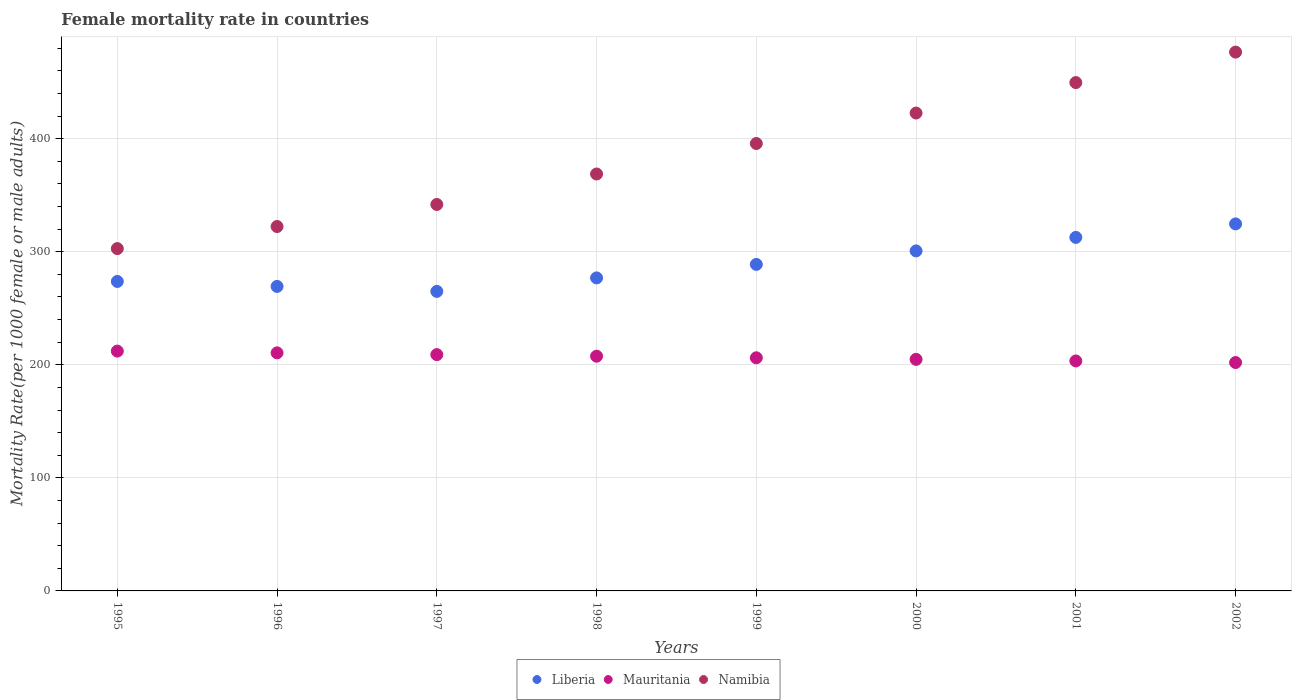How many different coloured dotlines are there?
Keep it short and to the point. 3. What is the female mortality rate in Namibia in 1996?
Your answer should be compact. 322.29. Across all years, what is the maximum female mortality rate in Mauritania?
Your response must be concise. 212.1. Across all years, what is the minimum female mortality rate in Namibia?
Keep it short and to the point. 302.77. What is the total female mortality rate in Namibia in the graph?
Keep it short and to the point. 3080.13. What is the difference between the female mortality rate in Mauritania in 1996 and that in 2001?
Provide a short and direct response. 7.15. What is the difference between the female mortality rate in Liberia in 1998 and the female mortality rate in Mauritania in 1999?
Your answer should be compact. 70.65. What is the average female mortality rate in Liberia per year?
Your response must be concise. 288.94. In the year 1998, what is the difference between the female mortality rate in Namibia and female mortality rate in Liberia?
Ensure brevity in your answer.  91.9. In how many years, is the female mortality rate in Mauritania greater than 180?
Your answer should be very brief. 8. What is the ratio of the female mortality rate in Namibia in 1996 to that in 1997?
Ensure brevity in your answer.  0.94. Is the female mortality rate in Liberia in 1997 less than that in 1999?
Keep it short and to the point. Yes. Is the difference between the female mortality rate in Namibia in 1998 and 2002 greater than the difference between the female mortality rate in Liberia in 1998 and 2002?
Provide a short and direct response. No. What is the difference between the highest and the second highest female mortality rate in Liberia?
Make the answer very short. 11.94. What is the difference between the highest and the lowest female mortality rate in Namibia?
Provide a short and direct response. 173.78. In how many years, is the female mortality rate in Liberia greater than the average female mortality rate in Liberia taken over all years?
Your response must be concise. 3. Is the sum of the female mortality rate in Mauritania in 1995 and 1999 greater than the maximum female mortality rate in Liberia across all years?
Make the answer very short. Yes. Is it the case that in every year, the sum of the female mortality rate in Namibia and female mortality rate in Mauritania  is greater than the female mortality rate in Liberia?
Give a very brief answer. Yes. Does the female mortality rate in Namibia monotonically increase over the years?
Your answer should be very brief. Yes. What is the difference between two consecutive major ticks on the Y-axis?
Provide a succinct answer. 100. Where does the legend appear in the graph?
Give a very brief answer. Bottom center. How many legend labels are there?
Provide a short and direct response. 3. What is the title of the graph?
Provide a succinct answer. Female mortality rate in countries. What is the label or title of the X-axis?
Make the answer very short. Years. What is the label or title of the Y-axis?
Give a very brief answer. Mortality Rate(per 1000 female or male adults). What is the Mortality Rate(per 1000 female or male adults) in Liberia in 1995?
Your response must be concise. 273.69. What is the Mortality Rate(per 1000 female or male adults) of Mauritania in 1995?
Your answer should be compact. 212.1. What is the Mortality Rate(per 1000 female or male adults) in Namibia in 1995?
Offer a terse response. 302.77. What is the Mortality Rate(per 1000 female or male adults) of Liberia in 1996?
Make the answer very short. 269.3. What is the Mortality Rate(per 1000 female or male adults) of Mauritania in 1996?
Your response must be concise. 210.55. What is the Mortality Rate(per 1000 female or male adults) of Namibia in 1996?
Give a very brief answer. 322.29. What is the Mortality Rate(per 1000 female or male adults) of Liberia in 1997?
Give a very brief answer. 264.91. What is the Mortality Rate(per 1000 female or male adults) in Mauritania in 1997?
Make the answer very short. 209. What is the Mortality Rate(per 1000 female or male adults) in Namibia in 1997?
Provide a succinct answer. 341.8. What is the Mortality Rate(per 1000 female or male adults) of Liberia in 1998?
Provide a short and direct response. 276.85. What is the Mortality Rate(per 1000 female or male adults) in Mauritania in 1998?
Keep it short and to the point. 207.6. What is the Mortality Rate(per 1000 female or male adults) of Namibia in 1998?
Your answer should be compact. 368.75. What is the Mortality Rate(per 1000 female or male adults) in Liberia in 1999?
Give a very brief answer. 288.79. What is the Mortality Rate(per 1000 female or male adults) of Mauritania in 1999?
Offer a very short reply. 206.2. What is the Mortality Rate(per 1000 female or male adults) of Namibia in 1999?
Your response must be concise. 395.7. What is the Mortality Rate(per 1000 female or male adults) of Liberia in 2000?
Keep it short and to the point. 300.73. What is the Mortality Rate(per 1000 female or male adults) in Mauritania in 2000?
Your answer should be very brief. 204.8. What is the Mortality Rate(per 1000 female or male adults) in Namibia in 2000?
Ensure brevity in your answer.  422.65. What is the Mortality Rate(per 1000 female or male adults) of Liberia in 2001?
Give a very brief answer. 312.67. What is the Mortality Rate(per 1000 female or male adults) in Mauritania in 2001?
Your answer should be very brief. 203.4. What is the Mortality Rate(per 1000 female or male adults) in Namibia in 2001?
Your answer should be compact. 449.61. What is the Mortality Rate(per 1000 female or male adults) of Liberia in 2002?
Make the answer very short. 324.61. What is the Mortality Rate(per 1000 female or male adults) in Mauritania in 2002?
Your answer should be compact. 202. What is the Mortality Rate(per 1000 female or male adults) in Namibia in 2002?
Your answer should be very brief. 476.56. Across all years, what is the maximum Mortality Rate(per 1000 female or male adults) in Liberia?
Provide a succinct answer. 324.61. Across all years, what is the maximum Mortality Rate(per 1000 female or male adults) of Mauritania?
Your answer should be compact. 212.1. Across all years, what is the maximum Mortality Rate(per 1000 female or male adults) of Namibia?
Provide a short and direct response. 476.56. Across all years, what is the minimum Mortality Rate(per 1000 female or male adults) in Liberia?
Keep it short and to the point. 264.91. Across all years, what is the minimum Mortality Rate(per 1000 female or male adults) in Mauritania?
Your answer should be very brief. 202. Across all years, what is the minimum Mortality Rate(per 1000 female or male adults) of Namibia?
Keep it short and to the point. 302.77. What is the total Mortality Rate(per 1000 female or male adults) of Liberia in the graph?
Provide a short and direct response. 2311.55. What is the total Mortality Rate(per 1000 female or male adults) in Mauritania in the graph?
Provide a short and direct response. 1655.65. What is the total Mortality Rate(per 1000 female or male adults) of Namibia in the graph?
Ensure brevity in your answer.  3080.13. What is the difference between the Mortality Rate(per 1000 female or male adults) in Liberia in 1995 and that in 1996?
Your answer should be very brief. 4.39. What is the difference between the Mortality Rate(per 1000 female or male adults) of Mauritania in 1995 and that in 1996?
Your answer should be compact. 1.55. What is the difference between the Mortality Rate(per 1000 female or male adults) of Namibia in 1995 and that in 1996?
Give a very brief answer. -19.51. What is the difference between the Mortality Rate(per 1000 female or male adults) of Liberia in 1995 and that in 1997?
Your answer should be compact. 8.78. What is the difference between the Mortality Rate(per 1000 female or male adults) in Mauritania in 1995 and that in 1997?
Keep it short and to the point. 3.1. What is the difference between the Mortality Rate(per 1000 female or male adults) of Namibia in 1995 and that in 1997?
Make the answer very short. -39.02. What is the difference between the Mortality Rate(per 1000 female or male adults) of Liberia in 1995 and that in 1998?
Offer a very short reply. -3.16. What is the difference between the Mortality Rate(per 1000 female or male adults) in Mauritania in 1995 and that in 1998?
Your response must be concise. 4.5. What is the difference between the Mortality Rate(per 1000 female or male adults) in Namibia in 1995 and that in 1998?
Your answer should be compact. -65.98. What is the difference between the Mortality Rate(per 1000 female or male adults) in Liberia in 1995 and that in 1999?
Offer a very short reply. -15.1. What is the difference between the Mortality Rate(per 1000 female or male adults) of Mauritania in 1995 and that in 1999?
Your response must be concise. 5.9. What is the difference between the Mortality Rate(per 1000 female or male adults) in Namibia in 1995 and that in 1999?
Your answer should be compact. -92.93. What is the difference between the Mortality Rate(per 1000 female or male adults) in Liberia in 1995 and that in 2000?
Offer a very short reply. -27.03. What is the difference between the Mortality Rate(per 1000 female or male adults) in Mauritania in 1995 and that in 2000?
Offer a terse response. 7.3. What is the difference between the Mortality Rate(per 1000 female or male adults) in Namibia in 1995 and that in 2000?
Your answer should be compact. -119.88. What is the difference between the Mortality Rate(per 1000 female or male adults) in Liberia in 1995 and that in 2001?
Your answer should be very brief. -38.97. What is the difference between the Mortality Rate(per 1000 female or male adults) of Mauritania in 1995 and that in 2001?
Offer a very short reply. 8.7. What is the difference between the Mortality Rate(per 1000 female or male adults) of Namibia in 1995 and that in 2001?
Your answer should be compact. -146.83. What is the difference between the Mortality Rate(per 1000 female or male adults) of Liberia in 1995 and that in 2002?
Make the answer very short. -50.91. What is the difference between the Mortality Rate(per 1000 female or male adults) of Mauritania in 1995 and that in 2002?
Your answer should be compact. 10.1. What is the difference between the Mortality Rate(per 1000 female or male adults) in Namibia in 1995 and that in 2002?
Make the answer very short. -173.78. What is the difference between the Mortality Rate(per 1000 female or male adults) of Liberia in 1996 and that in 1997?
Offer a terse response. 4.39. What is the difference between the Mortality Rate(per 1000 female or male adults) in Mauritania in 1996 and that in 1997?
Provide a succinct answer. 1.55. What is the difference between the Mortality Rate(per 1000 female or male adults) in Namibia in 1996 and that in 1997?
Offer a very short reply. -19.51. What is the difference between the Mortality Rate(per 1000 female or male adults) in Liberia in 1996 and that in 1998?
Give a very brief answer. -7.55. What is the difference between the Mortality Rate(per 1000 female or male adults) in Mauritania in 1996 and that in 1998?
Give a very brief answer. 2.95. What is the difference between the Mortality Rate(per 1000 female or male adults) of Namibia in 1996 and that in 1998?
Your answer should be compact. -46.46. What is the difference between the Mortality Rate(per 1000 female or male adults) of Liberia in 1996 and that in 1999?
Offer a terse response. -19.49. What is the difference between the Mortality Rate(per 1000 female or male adults) of Mauritania in 1996 and that in 1999?
Provide a succinct answer. 4.35. What is the difference between the Mortality Rate(per 1000 female or male adults) in Namibia in 1996 and that in 1999?
Offer a very short reply. -73.42. What is the difference between the Mortality Rate(per 1000 female or male adults) of Liberia in 1996 and that in 2000?
Offer a very short reply. -31.42. What is the difference between the Mortality Rate(per 1000 female or male adults) in Mauritania in 1996 and that in 2000?
Offer a very short reply. 5.75. What is the difference between the Mortality Rate(per 1000 female or male adults) of Namibia in 1996 and that in 2000?
Keep it short and to the point. -100.37. What is the difference between the Mortality Rate(per 1000 female or male adults) of Liberia in 1996 and that in 2001?
Ensure brevity in your answer.  -43.36. What is the difference between the Mortality Rate(per 1000 female or male adults) in Mauritania in 1996 and that in 2001?
Your answer should be very brief. 7.15. What is the difference between the Mortality Rate(per 1000 female or male adults) of Namibia in 1996 and that in 2001?
Your answer should be very brief. -127.32. What is the difference between the Mortality Rate(per 1000 female or male adults) in Liberia in 1996 and that in 2002?
Ensure brevity in your answer.  -55.3. What is the difference between the Mortality Rate(per 1000 female or male adults) of Mauritania in 1996 and that in 2002?
Your response must be concise. 8.55. What is the difference between the Mortality Rate(per 1000 female or male adults) of Namibia in 1996 and that in 2002?
Your answer should be very brief. -154.27. What is the difference between the Mortality Rate(per 1000 female or male adults) of Liberia in 1997 and that in 1998?
Keep it short and to the point. -11.94. What is the difference between the Mortality Rate(per 1000 female or male adults) of Mauritania in 1997 and that in 1998?
Your answer should be compact. 1.4. What is the difference between the Mortality Rate(per 1000 female or male adults) in Namibia in 1997 and that in 1998?
Your response must be concise. -26.95. What is the difference between the Mortality Rate(per 1000 female or male adults) of Liberia in 1997 and that in 1999?
Provide a short and direct response. -23.88. What is the difference between the Mortality Rate(per 1000 female or male adults) in Namibia in 1997 and that in 1999?
Provide a succinct answer. -53.9. What is the difference between the Mortality Rate(per 1000 female or male adults) of Liberia in 1997 and that in 2000?
Your response must be concise. -35.81. What is the difference between the Mortality Rate(per 1000 female or male adults) in Mauritania in 1997 and that in 2000?
Offer a terse response. 4.2. What is the difference between the Mortality Rate(per 1000 female or male adults) in Namibia in 1997 and that in 2000?
Keep it short and to the point. -80.86. What is the difference between the Mortality Rate(per 1000 female or male adults) of Liberia in 1997 and that in 2001?
Ensure brevity in your answer.  -47.75. What is the difference between the Mortality Rate(per 1000 female or male adults) of Namibia in 1997 and that in 2001?
Your response must be concise. -107.81. What is the difference between the Mortality Rate(per 1000 female or male adults) in Liberia in 1997 and that in 2002?
Your answer should be very brief. -59.69. What is the difference between the Mortality Rate(per 1000 female or male adults) of Namibia in 1997 and that in 2002?
Ensure brevity in your answer.  -134.76. What is the difference between the Mortality Rate(per 1000 female or male adults) in Liberia in 1998 and that in 1999?
Provide a succinct answer. -11.94. What is the difference between the Mortality Rate(per 1000 female or male adults) of Namibia in 1998 and that in 1999?
Your response must be concise. -26.95. What is the difference between the Mortality Rate(per 1000 female or male adults) of Liberia in 1998 and that in 2000?
Your response must be concise. -23.88. What is the difference between the Mortality Rate(per 1000 female or male adults) in Mauritania in 1998 and that in 2000?
Offer a very short reply. 2.8. What is the difference between the Mortality Rate(per 1000 female or male adults) of Namibia in 1998 and that in 2000?
Your response must be concise. -53.9. What is the difference between the Mortality Rate(per 1000 female or male adults) of Liberia in 1998 and that in 2001?
Your answer should be compact. -35.81. What is the difference between the Mortality Rate(per 1000 female or male adults) of Namibia in 1998 and that in 2001?
Provide a succinct answer. -80.86. What is the difference between the Mortality Rate(per 1000 female or male adults) in Liberia in 1998 and that in 2002?
Ensure brevity in your answer.  -47.75. What is the difference between the Mortality Rate(per 1000 female or male adults) of Namibia in 1998 and that in 2002?
Provide a short and direct response. -107.81. What is the difference between the Mortality Rate(per 1000 female or male adults) of Liberia in 1999 and that in 2000?
Offer a very short reply. -11.94. What is the difference between the Mortality Rate(per 1000 female or male adults) in Namibia in 1999 and that in 2000?
Ensure brevity in your answer.  -26.95. What is the difference between the Mortality Rate(per 1000 female or male adults) of Liberia in 1999 and that in 2001?
Offer a very short reply. -23.88. What is the difference between the Mortality Rate(per 1000 female or male adults) in Namibia in 1999 and that in 2001?
Make the answer very short. -53.9. What is the difference between the Mortality Rate(per 1000 female or male adults) in Liberia in 1999 and that in 2002?
Provide a succinct answer. -35.81. What is the difference between the Mortality Rate(per 1000 female or male adults) of Namibia in 1999 and that in 2002?
Offer a terse response. -80.86. What is the difference between the Mortality Rate(per 1000 female or male adults) of Liberia in 2000 and that in 2001?
Give a very brief answer. -11.94. What is the difference between the Mortality Rate(per 1000 female or male adults) of Mauritania in 2000 and that in 2001?
Give a very brief answer. 1.4. What is the difference between the Mortality Rate(per 1000 female or male adults) of Namibia in 2000 and that in 2001?
Your answer should be compact. -26.95. What is the difference between the Mortality Rate(per 1000 female or male adults) of Liberia in 2000 and that in 2002?
Your response must be concise. -23.88. What is the difference between the Mortality Rate(per 1000 female or male adults) of Mauritania in 2000 and that in 2002?
Give a very brief answer. 2.8. What is the difference between the Mortality Rate(per 1000 female or male adults) in Namibia in 2000 and that in 2002?
Your answer should be very brief. -53.9. What is the difference between the Mortality Rate(per 1000 female or male adults) of Liberia in 2001 and that in 2002?
Your answer should be very brief. -11.94. What is the difference between the Mortality Rate(per 1000 female or male adults) of Namibia in 2001 and that in 2002?
Keep it short and to the point. -26.95. What is the difference between the Mortality Rate(per 1000 female or male adults) of Liberia in 1995 and the Mortality Rate(per 1000 female or male adults) of Mauritania in 1996?
Keep it short and to the point. 63.14. What is the difference between the Mortality Rate(per 1000 female or male adults) in Liberia in 1995 and the Mortality Rate(per 1000 female or male adults) in Namibia in 1996?
Your answer should be very brief. -48.59. What is the difference between the Mortality Rate(per 1000 female or male adults) of Mauritania in 1995 and the Mortality Rate(per 1000 female or male adults) of Namibia in 1996?
Give a very brief answer. -110.18. What is the difference between the Mortality Rate(per 1000 female or male adults) of Liberia in 1995 and the Mortality Rate(per 1000 female or male adults) of Mauritania in 1997?
Keep it short and to the point. 64.69. What is the difference between the Mortality Rate(per 1000 female or male adults) of Liberia in 1995 and the Mortality Rate(per 1000 female or male adults) of Namibia in 1997?
Provide a succinct answer. -68.1. What is the difference between the Mortality Rate(per 1000 female or male adults) of Mauritania in 1995 and the Mortality Rate(per 1000 female or male adults) of Namibia in 1997?
Your response must be concise. -129.69. What is the difference between the Mortality Rate(per 1000 female or male adults) in Liberia in 1995 and the Mortality Rate(per 1000 female or male adults) in Mauritania in 1998?
Provide a short and direct response. 66.09. What is the difference between the Mortality Rate(per 1000 female or male adults) of Liberia in 1995 and the Mortality Rate(per 1000 female or male adults) of Namibia in 1998?
Provide a succinct answer. -95.06. What is the difference between the Mortality Rate(per 1000 female or male adults) of Mauritania in 1995 and the Mortality Rate(per 1000 female or male adults) of Namibia in 1998?
Make the answer very short. -156.65. What is the difference between the Mortality Rate(per 1000 female or male adults) in Liberia in 1995 and the Mortality Rate(per 1000 female or male adults) in Mauritania in 1999?
Provide a succinct answer. 67.5. What is the difference between the Mortality Rate(per 1000 female or male adults) of Liberia in 1995 and the Mortality Rate(per 1000 female or male adults) of Namibia in 1999?
Your response must be concise. -122.01. What is the difference between the Mortality Rate(per 1000 female or male adults) of Mauritania in 1995 and the Mortality Rate(per 1000 female or male adults) of Namibia in 1999?
Offer a very short reply. -183.6. What is the difference between the Mortality Rate(per 1000 female or male adults) in Liberia in 1995 and the Mortality Rate(per 1000 female or male adults) in Mauritania in 2000?
Offer a very short reply. 68.89. What is the difference between the Mortality Rate(per 1000 female or male adults) of Liberia in 1995 and the Mortality Rate(per 1000 female or male adults) of Namibia in 2000?
Offer a terse response. -148.96. What is the difference between the Mortality Rate(per 1000 female or male adults) of Mauritania in 1995 and the Mortality Rate(per 1000 female or male adults) of Namibia in 2000?
Offer a very short reply. -210.55. What is the difference between the Mortality Rate(per 1000 female or male adults) in Liberia in 1995 and the Mortality Rate(per 1000 female or male adults) in Mauritania in 2001?
Provide a short and direct response. 70.3. What is the difference between the Mortality Rate(per 1000 female or male adults) of Liberia in 1995 and the Mortality Rate(per 1000 female or male adults) of Namibia in 2001?
Provide a succinct answer. -175.91. What is the difference between the Mortality Rate(per 1000 female or male adults) of Mauritania in 1995 and the Mortality Rate(per 1000 female or male adults) of Namibia in 2001?
Offer a very short reply. -237.5. What is the difference between the Mortality Rate(per 1000 female or male adults) of Liberia in 1995 and the Mortality Rate(per 1000 female or male adults) of Mauritania in 2002?
Ensure brevity in your answer.  71.69. What is the difference between the Mortality Rate(per 1000 female or male adults) in Liberia in 1995 and the Mortality Rate(per 1000 female or male adults) in Namibia in 2002?
Your answer should be very brief. -202.86. What is the difference between the Mortality Rate(per 1000 female or male adults) in Mauritania in 1995 and the Mortality Rate(per 1000 female or male adults) in Namibia in 2002?
Ensure brevity in your answer.  -264.45. What is the difference between the Mortality Rate(per 1000 female or male adults) of Liberia in 1996 and the Mortality Rate(per 1000 female or male adults) of Mauritania in 1997?
Keep it short and to the point. 60.3. What is the difference between the Mortality Rate(per 1000 female or male adults) of Liberia in 1996 and the Mortality Rate(per 1000 female or male adults) of Namibia in 1997?
Your answer should be compact. -72.49. What is the difference between the Mortality Rate(per 1000 female or male adults) of Mauritania in 1996 and the Mortality Rate(per 1000 female or male adults) of Namibia in 1997?
Give a very brief answer. -131.25. What is the difference between the Mortality Rate(per 1000 female or male adults) in Liberia in 1996 and the Mortality Rate(per 1000 female or male adults) in Mauritania in 1998?
Offer a terse response. 61.7. What is the difference between the Mortality Rate(per 1000 female or male adults) in Liberia in 1996 and the Mortality Rate(per 1000 female or male adults) in Namibia in 1998?
Offer a very short reply. -99.45. What is the difference between the Mortality Rate(per 1000 female or male adults) in Mauritania in 1996 and the Mortality Rate(per 1000 female or male adults) in Namibia in 1998?
Your answer should be very brief. -158.2. What is the difference between the Mortality Rate(per 1000 female or male adults) of Liberia in 1996 and the Mortality Rate(per 1000 female or male adults) of Mauritania in 1999?
Your answer should be compact. 63.1. What is the difference between the Mortality Rate(per 1000 female or male adults) of Liberia in 1996 and the Mortality Rate(per 1000 female or male adults) of Namibia in 1999?
Your answer should be very brief. -126.4. What is the difference between the Mortality Rate(per 1000 female or male adults) in Mauritania in 1996 and the Mortality Rate(per 1000 female or male adults) in Namibia in 1999?
Your response must be concise. -185.15. What is the difference between the Mortality Rate(per 1000 female or male adults) of Liberia in 1996 and the Mortality Rate(per 1000 female or male adults) of Mauritania in 2000?
Your answer should be compact. 64.5. What is the difference between the Mortality Rate(per 1000 female or male adults) of Liberia in 1996 and the Mortality Rate(per 1000 female or male adults) of Namibia in 2000?
Provide a short and direct response. -153.35. What is the difference between the Mortality Rate(per 1000 female or male adults) of Mauritania in 1996 and the Mortality Rate(per 1000 female or male adults) of Namibia in 2000?
Your answer should be compact. -212.1. What is the difference between the Mortality Rate(per 1000 female or male adults) in Liberia in 1996 and the Mortality Rate(per 1000 female or male adults) in Mauritania in 2001?
Your answer should be compact. 65.9. What is the difference between the Mortality Rate(per 1000 female or male adults) in Liberia in 1996 and the Mortality Rate(per 1000 female or male adults) in Namibia in 2001?
Give a very brief answer. -180.3. What is the difference between the Mortality Rate(per 1000 female or male adults) in Mauritania in 1996 and the Mortality Rate(per 1000 female or male adults) in Namibia in 2001?
Make the answer very short. -239.05. What is the difference between the Mortality Rate(per 1000 female or male adults) in Liberia in 1996 and the Mortality Rate(per 1000 female or male adults) in Mauritania in 2002?
Your answer should be compact. 67.3. What is the difference between the Mortality Rate(per 1000 female or male adults) of Liberia in 1996 and the Mortality Rate(per 1000 female or male adults) of Namibia in 2002?
Your response must be concise. -207.25. What is the difference between the Mortality Rate(per 1000 female or male adults) in Mauritania in 1996 and the Mortality Rate(per 1000 female or male adults) in Namibia in 2002?
Offer a very short reply. -266.01. What is the difference between the Mortality Rate(per 1000 female or male adults) in Liberia in 1997 and the Mortality Rate(per 1000 female or male adults) in Mauritania in 1998?
Ensure brevity in your answer.  57.31. What is the difference between the Mortality Rate(per 1000 female or male adults) of Liberia in 1997 and the Mortality Rate(per 1000 female or male adults) of Namibia in 1998?
Your answer should be very brief. -103.84. What is the difference between the Mortality Rate(per 1000 female or male adults) of Mauritania in 1997 and the Mortality Rate(per 1000 female or male adults) of Namibia in 1998?
Ensure brevity in your answer.  -159.75. What is the difference between the Mortality Rate(per 1000 female or male adults) of Liberia in 1997 and the Mortality Rate(per 1000 female or male adults) of Mauritania in 1999?
Provide a succinct answer. 58.71. What is the difference between the Mortality Rate(per 1000 female or male adults) in Liberia in 1997 and the Mortality Rate(per 1000 female or male adults) in Namibia in 1999?
Your answer should be very brief. -130.79. What is the difference between the Mortality Rate(per 1000 female or male adults) of Mauritania in 1997 and the Mortality Rate(per 1000 female or male adults) of Namibia in 1999?
Provide a succinct answer. -186.7. What is the difference between the Mortality Rate(per 1000 female or male adults) in Liberia in 1997 and the Mortality Rate(per 1000 female or male adults) in Mauritania in 2000?
Provide a short and direct response. 60.11. What is the difference between the Mortality Rate(per 1000 female or male adults) of Liberia in 1997 and the Mortality Rate(per 1000 female or male adults) of Namibia in 2000?
Provide a short and direct response. -157.74. What is the difference between the Mortality Rate(per 1000 female or male adults) in Mauritania in 1997 and the Mortality Rate(per 1000 female or male adults) in Namibia in 2000?
Give a very brief answer. -213.65. What is the difference between the Mortality Rate(per 1000 female or male adults) in Liberia in 1997 and the Mortality Rate(per 1000 female or male adults) in Mauritania in 2001?
Ensure brevity in your answer.  61.51. What is the difference between the Mortality Rate(per 1000 female or male adults) in Liberia in 1997 and the Mortality Rate(per 1000 female or male adults) in Namibia in 2001?
Your answer should be very brief. -184.69. What is the difference between the Mortality Rate(per 1000 female or male adults) of Mauritania in 1997 and the Mortality Rate(per 1000 female or male adults) of Namibia in 2001?
Provide a succinct answer. -240.61. What is the difference between the Mortality Rate(per 1000 female or male adults) in Liberia in 1997 and the Mortality Rate(per 1000 female or male adults) in Mauritania in 2002?
Your answer should be very brief. 62.91. What is the difference between the Mortality Rate(per 1000 female or male adults) of Liberia in 1997 and the Mortality Rate(per 1000 female or male adults) of Namibia in 2002?
Provide a short and direct response. -211.64. What is the difference between the Mortality Rate(per 1000 female or male adults) of Mauritania in 1997 and the Mortality Rate(per 1000 female or male adults) of Namibia in 2002?
Provide a succinct answer. -267.56. What is the difference between the Mortality Rate(per 1000 female or male adults) of Liberia in 1998 and the Mortality Rate(per 1000 female or male adults) of Mauritania in 1999?
Ensure brevity in your answer.  70.65. What is the difference between the Mortality Rate(per 1000 female or male adults) in Liberia in 1998 and the Mortality Rate(per 1000 female or male adults) in Namibia in 1999?
Your answer should be very brief. -118.85. What is the difference between the Mortality Rate(per 1000 female or male adults) in Mauritania in 1998 and the Mortality Rate(per 1000 female or male adults) in Namibia in 1999?
Provide a short and direct response. -188.1. What is the difference between the Mortality Rate(per 1000 female or male adults) in Liberia in 1998 and the Mortality Rate(per 1000 female or male adults) in Mauritania in 2000?
Make the answer very short. 72.05. What is the difference between the Mortality Rate(per 1000 female or male adults) of Liberia in 1998 and the Mortality Rate(per 1000 female or male adults) of Namibia in 2000?
Give a very brief answer. -145.8. What is the difference between the Mortality Rate(per 1000 female or male adults) in Mauritania in 1998 and the Mortality Rate(per 1000 female or male adults) in Namibia in 2000?
Make the answer very short. -215.05. What is the difference between the Mortality Rate(per 1000 female or male adults) of Liberia in 1998 and the Mortality Rate(per 1000 female or male adults) of Mauritania in 2001?
Give a very brief answer. 73.45. What is the difference between the Mortality Rate(per 1000 female or male adults) of Liberia in 1998 and the Mortality Rate(per 1000 female or male adults) of Namibia in 2001?
Offer a terse response. -172.75. What is the difference between the Mortality Rate(per 1000 female or male adults) of Mauritania in 1998 and the Mortality Rate(per 1000 female or male adults) of Namibia in 2001?
Offer a very short reply. -242.01. What is the difference between the Mortality Rate(per 1000 female or male adults) of Liberia in 1998 and the Mortality Rate(per 1000 female or male adults) of Mauritania in 2002?
Your answer should be compact. 74.85. What is the difference between the Mortality Rate(per 1000 female or male adults) of Liberia in 1998 and the Mortality Rate(per 1000 female or male adults) of Namibia in 2002?
Keep it short and to the point. -199.71. What is the difference between the Mortality Rate(per 1000 female or male adults) of Mauritania in 1998 and the Mortality Rate(per 1000 female or male adults) of Namibia in 2002?
Offer a very short reply. -268.96. What is the difference between the Mortality Rate(per 1000 female or male adults) of Liberia in 1999 and the Mortality Rate(per 1000 female or male adults) of Mauritania in 2000?
Offer a terse response. 83.99. What is the difference between the Mortality Rate(per 1000 female or male adults) in Liberia in 1999 and the Mortality Rate(per 1000 female or male adults) in Namibia in 2000?
Provide a succinct answer. -133.86. What is the difference between the Mortality Rate(per 1000 female or male adults) in Mauritania in 1999 and the Mortality Rate(per 1000 female or male adults) in Namibia in 2000?
Offer a very short reply. -216.45. What is the difference between the Mortality Rate(per 1000 female or male adults) in Liberia in 1999 and the Mortality Rate(per 1000 female or male adults) in Mauritania in 2001?
Provide a short and direct response. 85.39. What is the difference between the Mortality Rate(per 1000 female or male adults) in Liberia in 1999 and the Mortality Rate(per 1000 female or male adults) in Namibia in 2001?
Ensure brevity in your answer.  -160.82. What is the difference between the Mortality Rate(per 1000 female or male adults) of Mauritania in 1999 and the Mortality Rate(per 1000 female or male adults) of Namibia in 2001?
Provide a short and direct response. -243.41. What is the difference between the Mortality Rate(per 1000 female or male adults) in Liberia in 1999 and the Mortality Rate(per 1000 female or male adults) in Mauritania in 2002?
Your answer should be very brief. 86.79. What is the difference between the Mortality Rate(per 1000 female or male adults) of Liberia in 1999 and the Mortality Rate(per 1000 female or male adults) of Namibia in 2002?
Make the answer very short. -187.77. What is the difference between the Mortality Rate(per 1000 female or male adults) in Mauritania in 1999 and the Mortality Rate(per 1000 female or male adults) in Namibia in 2002?
Your answer should be very brief. -270.36. What is the difference between the Mortality Rate(per 1000 female or male adults) in Liberia in 2000 and the Mortality Rate(per 1000 female or male adults) in Mauritania in 2001?
Make the answer very short. 97.33. What is the difference between the Mortality Rate(per 1000 female or male adults) in Liberia in 2000 and the Mortality Rate(per 1000 female or male adults) in Namibia in 2001?
Your answer should be compact. -148.88. What is the difference between the Mortality Rate(per 1000 female or male adults) in Mauritania in 2000 and the Mortality Rate(per 1000 female or male adults) in Namibia in 2001?
Keep it short and to the point. -244.81. What is the difference between the Mortality Rate(per 1000 female or male adults) in Liberia in 2000 and the Mortality Rate(per 1000 female or male adults) in Mauritania in 2002?
Your answer should be compact. 98.73. What is the difference between the Mortality Rate(per 1000 female or male adults) of Liberia in 2000 and the Mortality Rate(per 1000 female or male adults) of Namibia in 2002?
Make the answer very short. -175.83. What is the difference between the Mortality Rate(per 1000 female or male adults) in Mauritania in 2000 and the Mortality Rate(per 1000 female or male adults) in Namibia in 2002?
Make the answer very short. -271.76. What is the difference between the Mortality Rate(per 1000 female or male adults) in Liberia in 2001 and the Mortality Rate(per 1000 female or male adults) in Mauritania in 2002?
Your response must be concise. 110.67. What is the difference between the Mortality Rate(per 1000 female or male adults) in Liberia in 2001 and the Mortality Rate(per 1000 female or male adults) in Namibia in 2002?
Give a very brief answer. -163.89. What is the difference between the Mortality Rate(per 1000 female or male adults) of Mauritania in 2001 and the Mortality Rate(per 1000 female or male adults) of Namibia in 2002?
Ensure brevity in your answer.  -273.16. What is the average Mortality Rate(per 1000 female or male adults) of Liberia per year?
Offer a very short reply. 288.94. What is the average Mortality Rate(per 1000 female or male adults) in Mauritania per year?
Your answer should be compact. 206.96. What is the average Mortality Rate(per 1000 female or male adults) in Namibia per year?
Give a very brief answer. 385.02. In the year 1995, what is the difference between the Mortality Rate(per 1000 female or male adults) in Liberia and Mortality Rate(per 1000 female or male adults) in Mauritania?
Ensure brevity in your answer.  61.59. In the year 1995, what is the difference between the Mortality Rate(per 1000 female or male adults) in Liberia and Mortality Rate(per 1000 female or male adults) in Namibia?
Give a very brief answer. -29.08. In the year 1995, what is the difference between the Mortality Rate(per 1000 female or male adults) in Mauritania and Mortality Rate(per 1000 female or male adults) in Namibia?
Provide a short and direct response. -90.67. In the year 1996, what is the difference between the Mortality Rate(per 1000 female or male adults) in Liberia and Mortality Rate(per 1000 female or male adults) in Mauritania?
Provide a succinct answer. 58.75. In the year 1996, what is the difference between the Mortality Rate(per 1000 female or male adults) of Liberia and Mortality Rate(per 1000 female or male adults) of Namibia?
Keep it short and to the point. -52.98. In the year 1996, what is the difference between the Mortality Rate(per 1000 female or male adults) in Mauritania and Mortality Rate(per 1000 female or male adults) in Namibia?
Provide a short and direct response. -111.73. In the year 1997, what is the difference between the Mortality Rate(per 1000 female or male adults) in Liberia and Mortality Rate(per 1000 female or male adults) in Mauritania?
Make the answer very short. 55.91. In the year 1997, what is the difference between the Mortality Rate(per 1000 female or male adults) in Liberia and Mortality Rate(per 1000 female or male adults) in Namibia?
Give a very brief answer. -76.88. In the year 1997, what is the difference between the Mortality Rate(per 1000 female or male adults) in Mauritania and Mortality Rate(per 1000 female or male adults) in Namibia?
Keep it short and to the point. -132.8. In the year 1998, what is the difference between the Mortality Rate(per 1000 female or male adults) of Liberia and Mortality Rate(per 1000 female or male adults) of Mauritania?
Provide a succinct answer. 69.25. In the year 1998, what is the difference between the Mortality Rate(per 1000 female or male adults) of Liberia and Mortality Rate(per 1000 female or male adults) of Namibia?
Your answer should be very brief. -91.9. In the year 1998, what is the difference between the Mortality Rate(per 1000 female or male adults) of Mauritania and Mortality Rate(per 1000 female or male adults) of Namibia?
Ensure brevity in your answer.  -161.15. In the year 1999, what is the difference between the Mortality Rate(per 1000 female or male adults) in Liberia and Mortality Rate(per 1000 female or male adults) in Mauritania?
Ensure brevity in your answer.  82.59. In the year 1999, what is the difference between the Mortality Rate(per 1000 female or male adults) in Liberia and Mortality Rate(per 1000 female or male adults) in Namibia?
Keep it short and to the point. -106.91. In the year 1999, what is the difference between the Mortality Rate(per 1000 female or male adults) of Mauritania and Mortality Rate(per 1000 female or male adults) of Namibia?
Keep it short and to the point. -189.5. In the year 2000, what is the difference between the Mortality Rate(per 1000 female or male adults) of Liberia and Mortality Rate(per 1000 female or male adults) of Mauritania?
Make the answer very short. 95.93. In the year 2000, what is the difference between the Mortality Rate(per 1000 female or male adults) in Liberia and Mortality Rate(per 1000 female or male adults) in Namibia?
Offer a very short reply. -121.93. In the year 2000, what is the difference between the Mortality Rate(per 1000 female or male adults) of Mauritania and Mortality Rate(per 1000 female or male adults) of Namibia?
Offer a terse response. -217.85. In the year 2001, what is the difference between the Mortality Rate(per 1000 female or male adults) of Liberia and Mortality Rate(per 1000 female or male adults) of Mauritania?
Offer a terse response. 109.27. In the year 2001, what is the difference between the Mortality Rate(per 1000 female or male adults) of Liberia and Mortality Rate(per 1000 female or male adults) of Namibia?
Your answer should be very brief. -136.94. In the year 2001, what is the difference between the Mortality Rate(per 1000 female or male adults) in Mauritania and Mortality Rate(per 1000 female or male adults) in Namibia?
Your answer should be very brief. -246.21. In the year 2002, what is the difference between the Mortality Rate(per 1000 female or male adults) of Liberia and Mortality Rate(per 1000 female or male adults) of Mauritania?
Your answer should be compact. 122.61. In the year 2002, what is the difference between the Mortality Rate(per 1000 female or male adults) in Liberia and Mortality Rate(per 1000 female or male adults) in Namibia?
Offer a very short reply. -151.95. In the year 2002, what is the difference between the Mortality Rate(per 1000 female or male adults) in Mauritania and Mortality Rate(per 1000 female or male adults) in Namibia?
Provide a succinct answer. -274.56. What is the ratio of the Mortality Rate(per 1000 female or male adults) of Liberia in 1995 to that in 1996?
Keep it short and to the point. 1.02. What is the ratio of the Mortality Rate(per 1000 female or male adults) of Mauritania in 1995 to that in 1996?
Offer a terse response. 1.01. What is the ratio of the Mortality Rate(per 1000 female or male adults) in Namibia in 1995 to that in 1996?
Offer a very short reply. 0.94. What is the ratio of the Mortality Rate(per 1000 female or male adults) in Liberia in 1995 to that in 1997?
Offer a terse response. 1.03. What is the ratio of the Mortality Rate(per 1000 female or male adults) of Mauritania in 1995 to that in 1997?
Your answer should be very brief. 1.01. What is the ratio of the Mortality Rate(per 1000 female or male adults) of Namibia in 1995 to that in 1997?
Offer a terse response. 0.89. What is the ratio of the Mortality Rate(per 1000 female or male adults) of Liberia in 1995 to that in 1998?
Keep it short and to the point. 0.99. What is the ratio of the Mortality Rate(per 1000 female or male adults) of Mauritania in 1995 to that in 1998?
Your answer should be compact. 1.02. What is the ratio of the Mortality Rate(per 1000 female or male adults) of Namibia in 1995 to that in 1998?
Make the answer very short. 0.82. What is the ratio of the Mortality Rate(per 1000 female or male adults) of Liberia in 1995 to that in 1999?
Make the answer very short. 0.95. What is the ratio of the Mortality Rate(per 1000 female or male adults) in Mauritania in 1995 to that in 1999?
Keep it short and to the point. 1.03. What is the ratio of the Mortality Rate(per 1000 female or male adults) of Namibia in 1995 to that in 1999?
Give a very brief answer. 0.77. What is the ratio of the Mortality Rate(per 1000 female or male adults) of Liberia in 1995 to that in 2000?
Make the answer very short. 0.91. What is the ratio of the Mortality Rate(per 1000 female or male adults) in Mauritania in 1995 to that in 2000?
Make the answer very short. 1.04. What is the ratio of the Mortality Rate(per 1000 female or male adults) of Namibia in 1995 to that in 2000?
Give a very brief answer. 0.72. What is the ratio of the Mortality Rate(per 1000 female or male adults) of Liberia in 1995 to that in 2001?
Provide a short and direct response. 0.88. What is the ratio of the Mortality Rate(per 1000 female or male adults) of Mauritania in 1995 to that in 2001?
Provide a succinct answer. 1.04. What is the ratio of the Mortality Rate(per 1000 female or male adults) of Namibia in 1995 to that in 2001?
Your answer should be very brief. 0.67. What is the ratio of the Mortality Rate(per 1000 female or male adults) of Liberia in 1995 to that in 2002?
Keep it short and to the point. 0.84. What is the ratio of the Mortality Rate(per 1000 female or male adults) in Namibia in 1995 to that in 2002?
Offer a very short reply. 0.64. What is the ratio of the Mortality Rate(per 1000 female or male adults) in Liberia in 1996 to that in 1997?
Your response must be concise. 1.02. What is the ratio of the Mortality Rate(per 1000 female or male adults) in Mauritania in 1996 to that in 1997?
Offer a terse response. 1.01. What is the ratio of the Mortality Rate(per 1000 female or male adults) in Namibia in 1996 to that in 1997?
Your response must be concise. 0.94. What is the ratio of the Mortality Rate(per 1000 female or male adults) in Liberia in 1996 to that in 1998?
Provide a short and direct response. 0.97. What is the ratio of the Mortality Rate(per 1000 female or male adults) in Mauritania in 1996 to that in 1998?
Make the answer very short. 1.01. What is the ratio of the Mortality Rate(per 1000 female or male adults) in Namibia in 1996 to that in 1998?
Give a very brief answer. 0.87. What is the ratio of the Mortality Rate(per 1000 female or male adults) of Liberia in 1996 to that in 1999?
Make the answer very short. 0.93. What is the ratio of the Mortality Rate(per 1000 female or male adults) of Mauritania in 1996 to that in 1999?
Provide a short and direct response. 1.02. What is the ratio of the Mortality Rate(per 1000 female or male adults) in Namibia in 1996 to that in 1999?
Keep it short and to the point. 0.81. What is the ratio of the Mortality Rate(per 1000 female or male adults) in Liberia in 1996 to that in 2000?
Give a very brief answer. 0.9. What is the ratio of the Mortality Rate(per 1000 female or male adults) in Mauritania in 1996 to that in 2000?
Your response must be concise. 1.03. What is the ratio of the Mortality Rate(per 1000 female or male adults) in Namibia in 1996 to that in 2000?
Your answer should be compact. 0.76. What is the ratio of the Mortality Rate(per 1000 female or male adults) in Liberia in 1996 to that in 2001?
Make the answer very short. 0.86. What is the ratio of the Mortality Rate(per 1000 female or male adults) of Mauritania in 1996 to that in 2001?
Ensure brevity in your answer.  1.04. What is the ratio of the Mortality Rate(per 1000 female or male adults) of Namibia in 1996 to that in 2001?
Make the answer very short. 0.72. What is the ratio of the Mortality Rate(per 1000 female or male adults) in Liberia in 1996 to that in 2002?
Your answer should be compact. 0.83. What is the ratio of the Mortality Rate(per 1000 female or male adults) in Mauritania in 1996 to that in 2002?
Offer a terse response. 1.04. What is the ratio of the Mortality Rate(per 1000 female or male adults) in Namibia in 1996 to that in 2002?
Offer a terse response. 0.68. What is the ratio of the Mortality Rate(per 1000 female or male adults) of Liberia in 1997 to that in 1998?
Offer a terse response. 0.96. What is the ratio of the Mortality Rate(per 1000 female or male adults) of Namibia in 1997 to that in 1998?
Ensure brevity in your answer.  0.93. What is the ratio of the Mortality Rate(per 1000 female or male adults) in Liberia in 1997 to that in 1999?
Give a very brief answer. 0.92. What is the ratio of the Mortality Rate(per 1000 female or male adults) in Mauritania in 1997 to that in 1999?
Keep it short and to the point. 1.01. What is the ratio of the Mortality Rate(per 1000 female or male adults) in Namibia in 1997 to that in 1999?
Offer a terse response. 0.86. What is the ratio of the Mortality Rate(per 1000 female or male adults) in Liberia in 1997 to that in 2000?
Offer a terse response. 0.88. What is the ratio of the Mortality Rate(per 1000 female or male adults) in Mauritania in 1997 to that in 2000?
Ensure brevity in your answer.  1.02. What is the ratio of the Mortality Rate(per 1000 female or male adults) in Namibia in 1997 to that in 2000?
Give a very brief answer. 0.81. What is the ratio of the Mortality Rate(per 1000 female or male adults) in Liberia in 1997 to that in 2001?
Offer a very short reply. 0.85. What is the ratio of the Mortality Rate(per 1000 female or male adults) in Mauritania in 1997 to that in 2001?
Your response must be concise. 1.03. What is the ratio of the Mortality Rate(per 1000 female or male adults) in Namibia in 1997 to that in 2001?
Keep it short and to the point. 0.76. What is the ratio of the Mortality Rate(per 1000 female or male adults) in Liberia in 1997 to that in 2002?
Your answer should be compact. 0.82. What is the ratio of the Mortality Rate(per 1000 female or male adults) of Mauritania in 1997 to that in 2002?
Provide a succinct answer. 1.03. What is the ratio of the Mortality Rate(per 1000 female or male adults) of Namibia in 1997 to that in 2002?
Your answer should be very brief. 0.72. What is the ratio of the Mortality Rate(per 1000 female or male adults) of Liberia in 1998 to that in 1999?
Make the answer very short. 0.96. What is the ratio of the Mortality Rate(per 1000 female or male adults) of Mauritania in 1998 to that in 1999?
Offer a terse response. 1.01. What is the ratio of the Mortality Rate(per 1000 female or male adults) of Namibia in 1998 to that in 1999?
Provide a succinct answer. 0.93. What is the ratio of the Mortality Rate(per 1000 female or male adults) in Liberia in 1998 to that in 2000?
Offer a very short reply. 0.92. What is the ratio of the Mortality Rate(per 1000 female or male adults) in Mauritania in 1998 to that in 2000?
Your answer should be very brief. 1.01. What is the ratio of the Mortality Rate(per 1000 female or male adults) in Namibia in 1998 to that in 2000?
Give a very brief answer. 0.87. What is the ratio of the Mortality Rate(per 1000 female or male adults) in Liberia in 1998 to that in 2001?
Your answer should be compact. 0.89. What is the ratio of the Mortality Rate(per 1000 female or male adults) of Mauritania in 1998 to that in 2001?
Keep it short and to the point. 1.02. What is the ratio of the Mortality Rate(per 1000 female or male adults) in Namibia in 1998 to that in 2001?
Provide a short and direct response. 0.82. What is the ratio of the Mortality Rate(per 1000 female or male adults) in Liberia in 1998 to that in 2002?
Make the answer very short. 0.85. What is the ratio of the Mortality Rate(per 1000 female or male adults) of Mauritania in 1998 to that in 2002?
Keep it short and to the point. 1.03. What is the ratio of the Mortality Rate(per 1000 female or male adults) of Namibia in 1998 to that in 2002?
Offer a very short reply. 0.77. What is the ratio of the Mortality Rate(per 1000 female or male adults) in Liberia in 1999 to that in 2000?
Your answer should be very brief. 0.96. What is the ratio of the Mortality Rate(per 1000 female or male adults) in Mauritania in 1999 to that in 2000?
Give a very brief answer. 1.01. What is the ratio of the Mortality Rate(per 1000 female or male adults) in Namibia in 1999 to that in 2000?
Your answer should be compact. 0.94. What is the ratio of the Mortality Rate(per 1000 female or male adults) of Liberia in 1999 to that in 2001?
Ensure brevity in your answer.  0.92. What is the ratio of the Mortality Rate(per 1000 female or male adults) in Mauritania in 1999 to that in 2001?
Provide a succinct answer. 1.01. What is the ratio of the Mortality Rate(per 1000 female or male adults) in Namibia in 1999 to that in 2001?
Make the answer very short. 0.88. What is the ratio of the Mortality Rate(per 1000 female or male adults) in Liberia in 1999 to that in 2002?
Provide a succinct answer. 0.89. What is the ratio of the Mortality Rate(per 1000 female or male adults) in Mauritania in 1999 to that in 2002?
Provide a succinct answer. 1.02. What is the ratio of the Mortality Rate(per 1000 female or male adults) in Namibia in 1999 to that in 2002?
Your response must be concise. 0.83. What is the ratio of the Mortality Rate(per 1000 female or male adults) in Liberia in 2000 to that in 2001?
Give a very brief answer. 0.96. What is the ratio of the Mortality Rate(per 1000 female or male adults) in Mauritania in 2000 to that in 2001?
Offer a terse response. 1.01. What is the ratio of the Mortality Rate(per 1000 female or male adults) of Namibia in 2000 to that in 2001?
Your answer should be very brief. 0.94. What is the ratio of the Mortality Rate(per 1000 female or male adults) in Liberia in 2000 to that in 2002?
Provide a succinct answer. 0.93. What is the ratio of the Mortality Rate(per 1000 female or male adults) of Mauritania in 2000 to that in 2002?
Give a very brief answer. 1.01. What is the ratio of the Mortality Rate(per 1000 female or male adults) of Namibia in 2000 to that in 2002?
Provide a short and direct response. 0.89. What is the ratio of the Mortality Rate(per 1000 female or male adults) of Liberia in 2001 to that in 2002?
Keep it short and to the point. 0.96. What is the ratio of the Mortality Rate(per 1000 female or male adults) in Namibia in 2001 to that in 2002?
Your response must be concise. 0.94. What is the difference between the highest and the second highest Mortality Rate(per 1000 female or male adults) in Liberia?
Provide a succinct answer. 11.94. What is the difference between the highest and the second highest Mortality Rate(per 1000 female or male adults) in Mauritania?
Give a very brief answer. 1.55. What is the difference between the highest and the second highest Mortality Rate(per 1000 female or male adults) in Namibia?
Give a very brief answer. 26.95. What is the difference between the highest and the lowest Mortality Rate(per 1000 female or male adults) in Liberia?
Provide a succinct answer. 59.69. What is the difference between the highest and the lowest Mortality Rate(per 1000 female or male adults) of Mauritania?
Provide a short and direct response. 10.1. What is the difference between the highest and the lowest Mortality Rate(per 1000 female or male adults) of Namibia?
Give a very brief answer. 173.78. 